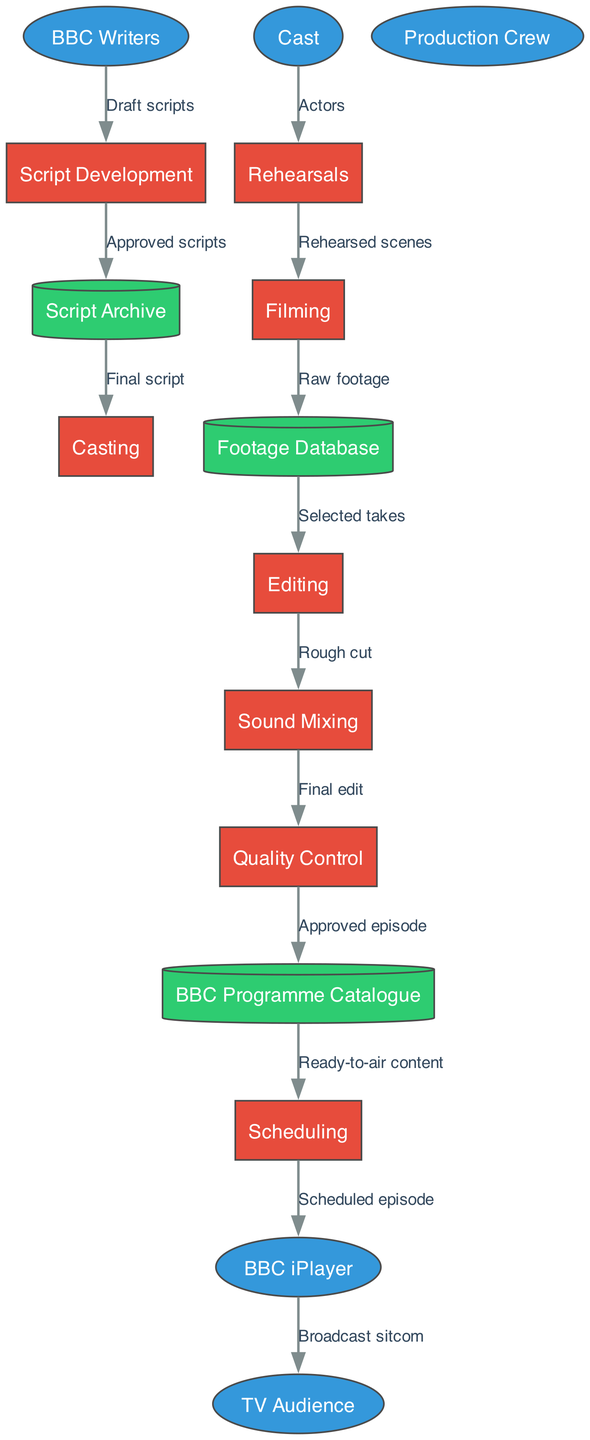What are the external entities involved in the production workflow? The external entities are listed as BBC Writers, Cast, Production Crew, BBC iPlayer, and TV Audience, which can be identified from the diagram as ellipses that denote outside actors in the workflow.
Answer: BBC Writers, Cast, Production Crew, BBC iPlayer, TV Audience How many processes are present in the diagram? The processes can be counted directly in the diagram. They include Script Development, Casting, Rehearsals, Filming, Editing, Sound Mixing, Quality Control, and Scheduling. Counting these nodes results in eight processes.
Answer: 8 What is the label of the data flow from Filming to Footage Database? By examining the edge between the Filming process and the Footage Database, the label indicates the type of data being transferred. The label is "Raw footage," which is a direct flow from the filming stage to the footage storage.
Answer: Raw footage Which process immediately follows Rehearsals in the workflow? The diagram shows the flow from Rehearsals leads directly to Filming. By following the arrows that depict the order of the production workflow, Filming is the next process.
Answer: Filming What does Quality Control receive as input? To determine the input for Quality Control, we look for the data flow that connects to it. From the diagram, Quality Control receives "Final edit" as input from Sound Mixing.
Answer: Final edit How does the BBC iPlayer receive the final content for broadcasting? To find out how the BBC iPlayer gets the content, we trace the path from Scheduling. The scheduled episode flows from the BBC Programme Catalogue into Scheduling, which then leads to the BBC iPlayer for broadcasting.
Answer: Scheduled episode What type of data does the script archive provide to the casting process? When analyzing the flows in the diagram, it's clear that the Script Archive sends "Final script" to Casting, which is the specific data type exchanged in this workflow step.
Answer: Final script Which entity receives the broadcast sitcom? The final step in the data flow shows that the broadcast sitcom is delivered to the TV Audience from BBC iPlayer, which is the last connection depicted.
Answer: TV Audience 